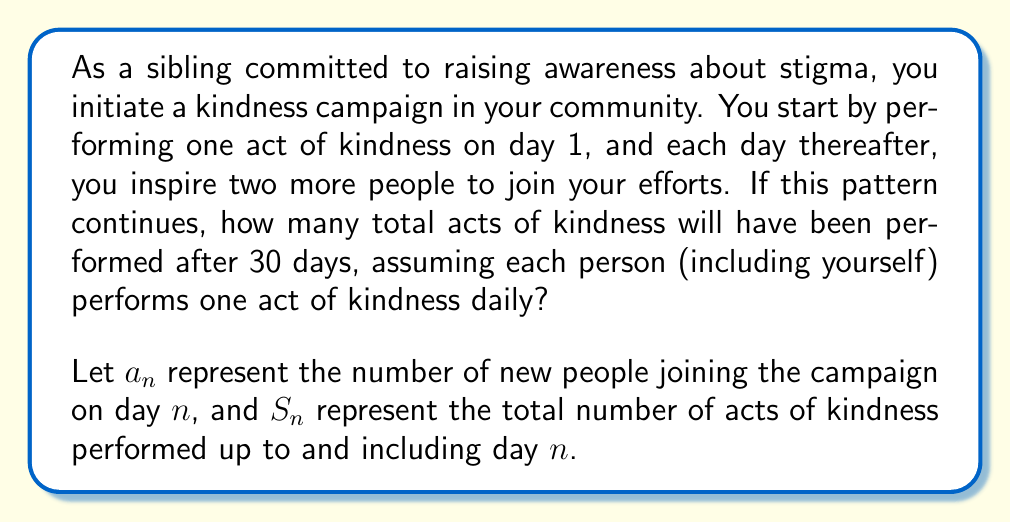Provide a solution to this math problem. To solve this problem, we need to understand the exponential growth of participants and the cumulative effect of their daily acts of kindness.

1) First, let's determine the number of new people joining each day:
   Day 1: $a_1 = 1$ (you)
   Day 2: $a_2 = 2$ (two people you inspired)
   Day 3: $a_3 = 2^2 = 4$ (two people inspired by each of the previous day's participants)
   Day 4: $a_4 = 2^3 = 8$

   We can see that for any day $n$, $a_n = 2^{n-1}$

2) Now, let's calculate the total number of participants up to day $n$:
   $S_n = \sum_{i=1}^n a_i = \sum_{i=1}^n 2^{i-1} = 2^n - 1$

3) Since each participant performs one act of kindness daily, the total number of acts on day $n$ is equal to the total number of participants up to that day.

4) To find the total number of acts over all 30 days, we need to sum the daily totals:

   $$\text{Total Acts} = \sum_{n=1}^{30} S_n = \sum_{n=1}^{30} (2^n - 1)$$

5) This can be simplified using the formula for the sum of geometric series:

   $$\sum_{n=1}^{30} 2^n = 2(2^{30} - 1)$$

6) Therefore, our final calculation is:

   $$\text{Total Acts} = 2(2^{30} - 1) - 30$$

7) Computing this value:

   $$\text{Total Acts} = 2(1,073,741,824 - 1) - 30 = 2,147,483,618$$
Answer: 2,147,483,618 acts of kindness 